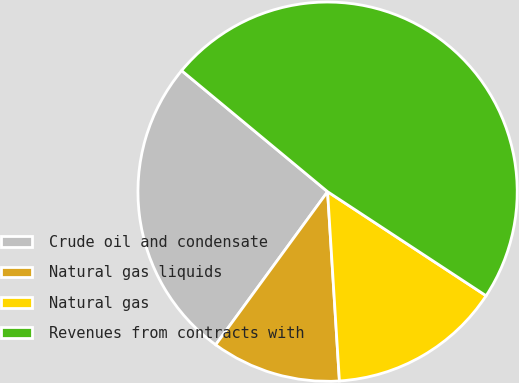Convert chart. <chart><loc_0><loc_0><loc_500><loc_500><pie_chart><fcel>Crude oil and condensate<fcel>Natural gas liquids<fcel>Natural gas<fcel>Revenues from contracts with<nl><fcel>25.98%<fcel>11.04%<fcel>14.76%<fcel>48.23%<nl></chart> 